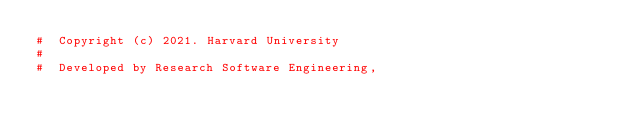<code> <loc_0><loc_0><loc_500><loc_500><_Python_>#  Copyright (c) 2021. Harvard University
#
#  Developed by Research Software Engineering,</code> 